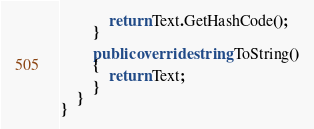<code> <loc_0><loc_0><loc_500><loc_500><_C#_>            return Text.GetHashCode();
        }

        public override string ToString()
        {
            return Text;
        }
    }
}</code> 